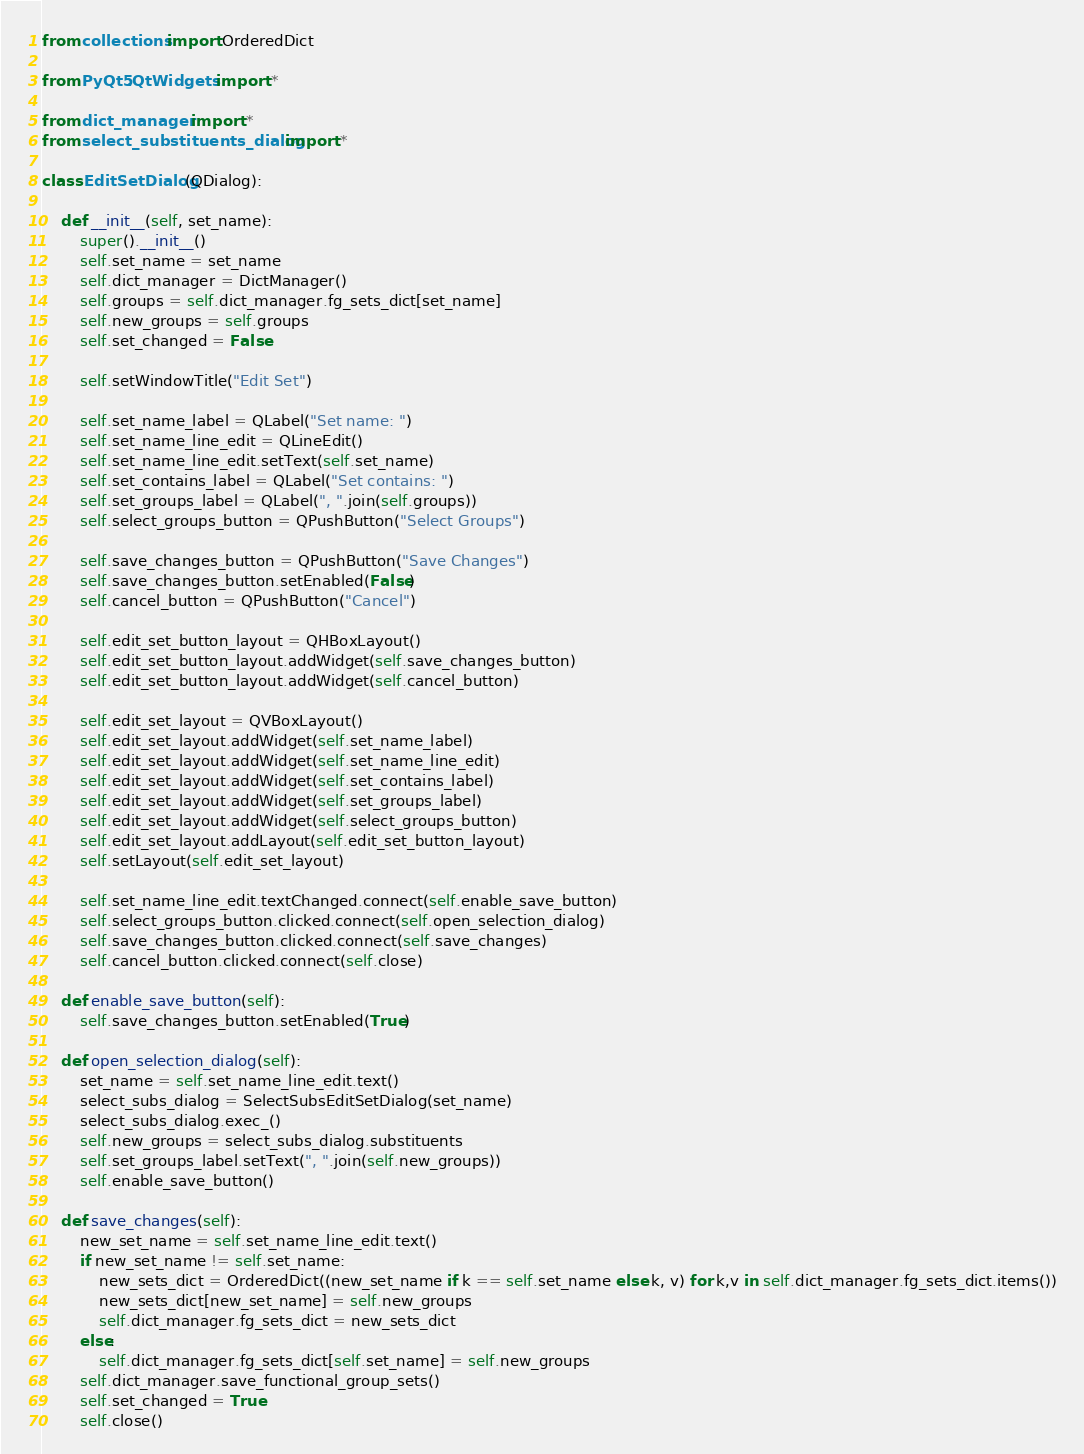Convert code to text. <code><loc_0><loc_0><loc_500><loc_500><_Python_>from collections import OrderedDict

from PyQt5.QtWidgets import *

from dict_manager import *
from select_substituents_dialog import *

class EditSetDialog(QDialog):

    def __init__(self, set_name):
        super().__init__()
        self.set_name = set_name
        self.dict_manager = DictManager()
        self.groups = self.dict_manager.fg_sets_dict[set_name]
        self.new_groups = self.groups
        self.set_changed = False

        self.setWindowTitle("Edit Set")

        self.set_name_label = QLabel("Set name: ")
        self.set_name_line_edit = QLineEdit()
        self.set_name_line_edit.setText(self.set_name)
        self.set_contains_label = QLabel("Set contains: ")
        self.set_groups_label = QLabel(", ".join(self.groups))
        self.select_groups_button = QPushButton("Select Groups")
      
        self.save_changes_button = QPushButton("Save Changes")
        self.save_changes_button.setEnabled(False)
        self.cancel_button = QPushButton("Cancel")

        self.edit_set_button_layout = QHBoxLayout()
        self.edit_set_button_layout.addWidget(self.save_changes_button)
        self.edit_set_button_layout.addWidget(self.cancel_button)

        self.edit_set_layout = QVBoxLayout()
        self.edit_set_layout.addWidget(self.set_name_label)
        self.edit_set_layout.addWidget(self.set_name_line_edit)
        self.edit_set_layout.addWidget(self.set_contains_label)
        self.edit_set_layout.addWidget(self.set_groups_label)
        self.edit_set_layout.addWidget(self.select_groups_button)
        self.edit_set_layout.addLayout(self.edit_set_button_layout)
        self.setLayout(self.edit_set_layout)

        self.set_name_line_edit.textChanged.connect(self.enable_save_button)
        self.select_groups_button.clicked.connect(self.open_selection_dialog)
        self.save_changes_button.clicked.connect(self.save_changes)
        self.cancel_button.clicked.connect(self.close)

    def enable_save_button(self):
        self.save_changes_button.setEnabled(True)

    def open_selection_dialog(self):
        set_name = self.set_name_line_edit.text()
        select_subs_dialog = SelectSubsEditSetDialog(set_name)
        select_subs_dialog.exec_()
        self.new_groups = select_subs_dialog.substituents
        self.set_groups_label.setText(", ".join(self.new_groups))
        self.enable_save_button()

    def save_changes(self):
        new_set_name = self.set_name_line_edit.text()
        if new_set_name != self.set_name:
            new_sets_dict = OrderedDict((new_set_name if k == self.set_name else k, v) for k,v in self.dict_manager.fg_sets_dict.items())
            new_sets_dict[new_set_name] = self.new_groups
            self.dict_manager.fg_sets_dict = new_sets_dict 
        else:
            self.dict_manager.fg_sets_dict[self.set_name] = self.new_groups
        self.dict_manager.save_functional_group_sets()
        self.set_changed = True
        self.close()
</code> 